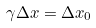Convert formula to latex. <formula><loc_0><loc_0><loc_500><loc_500>\gamma \Delta x = \Delta x _ { 0 }</formula> 